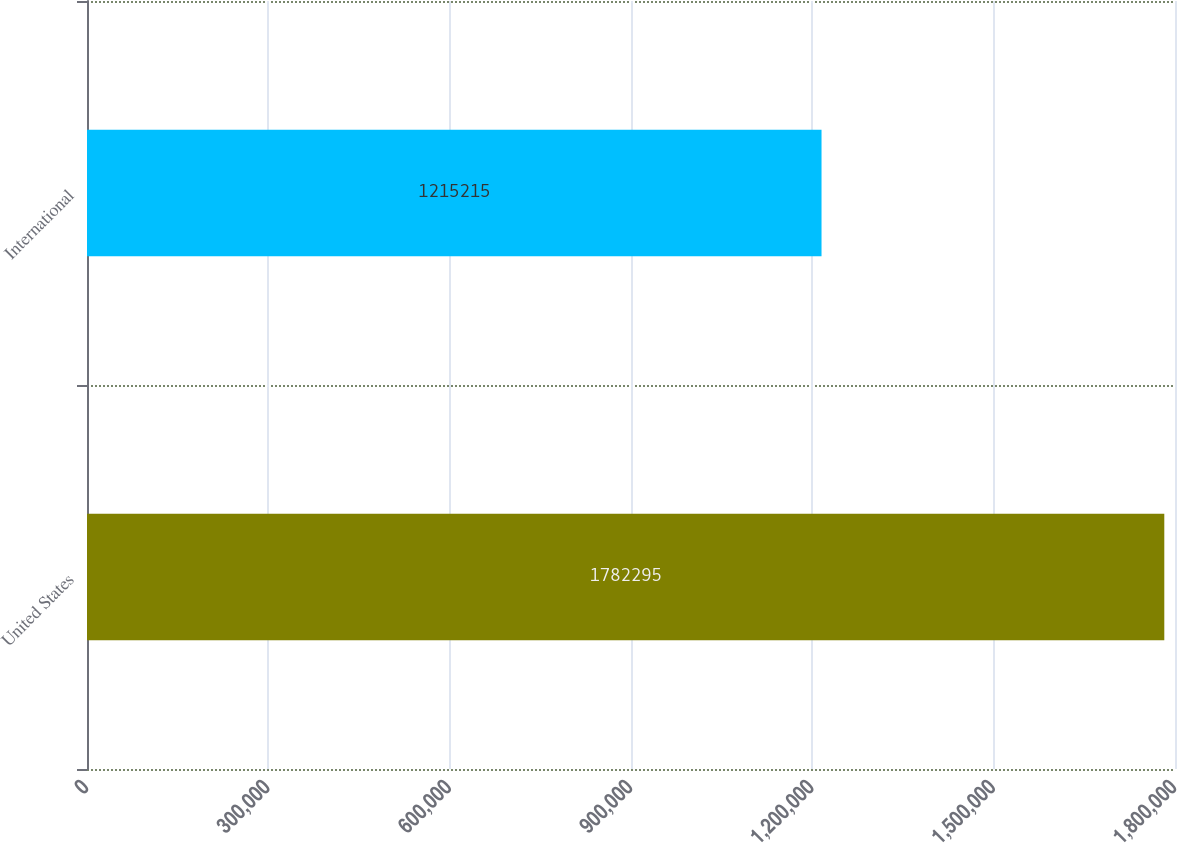Convert chart. <chart><loc_0><loc_0><loc_500><loc_500><bar_chart><fcel>United States<fcel>International<nl><fcel>1.7823e+06<fcel>1.21522e+06<nl></chart> 